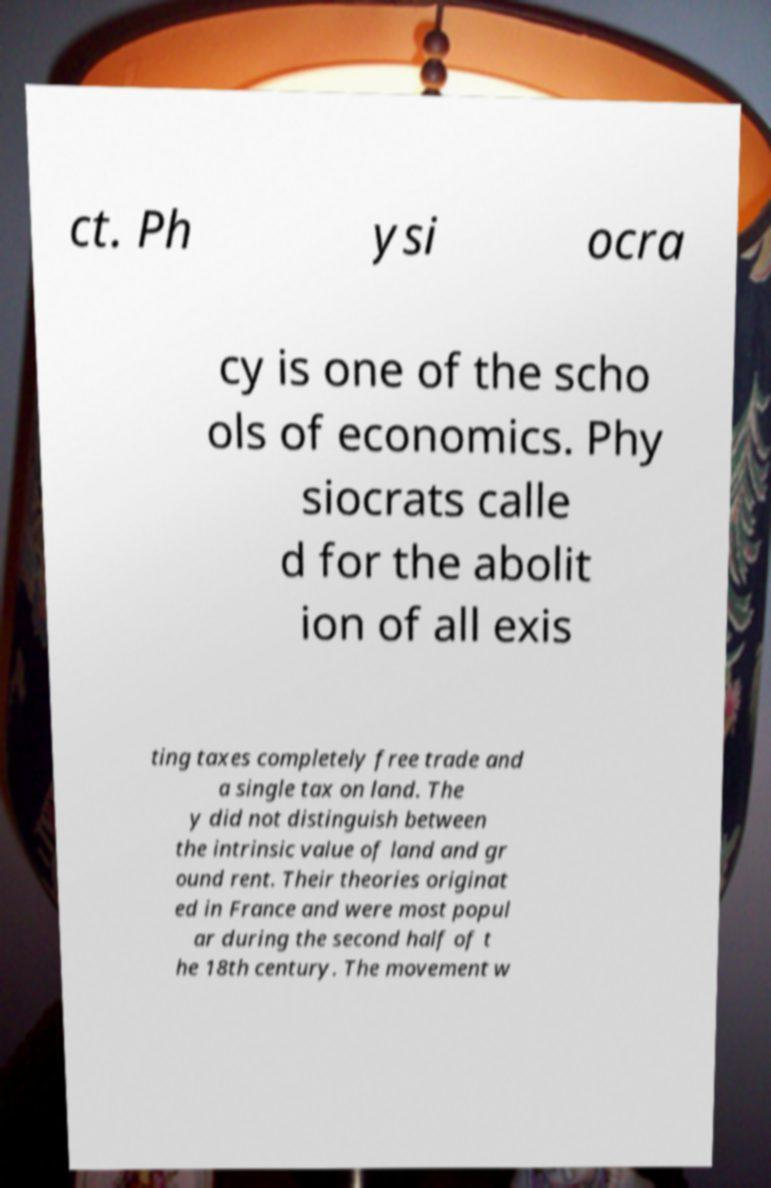There's text embedded in this image that I need extracted. Can you transcribe it verbatim? ct. Ph ysi ocra cy is one of the scho ols of economics. Phy siocrats calle d for the abolit ion of all exis ting taxes completely free trade and a single tax on land. The y did not distinguish between the intrinsic value of land and gr ound rent. Their theories originat ed in France and were most popul ar during the second half of t he 18th century. The movement w 